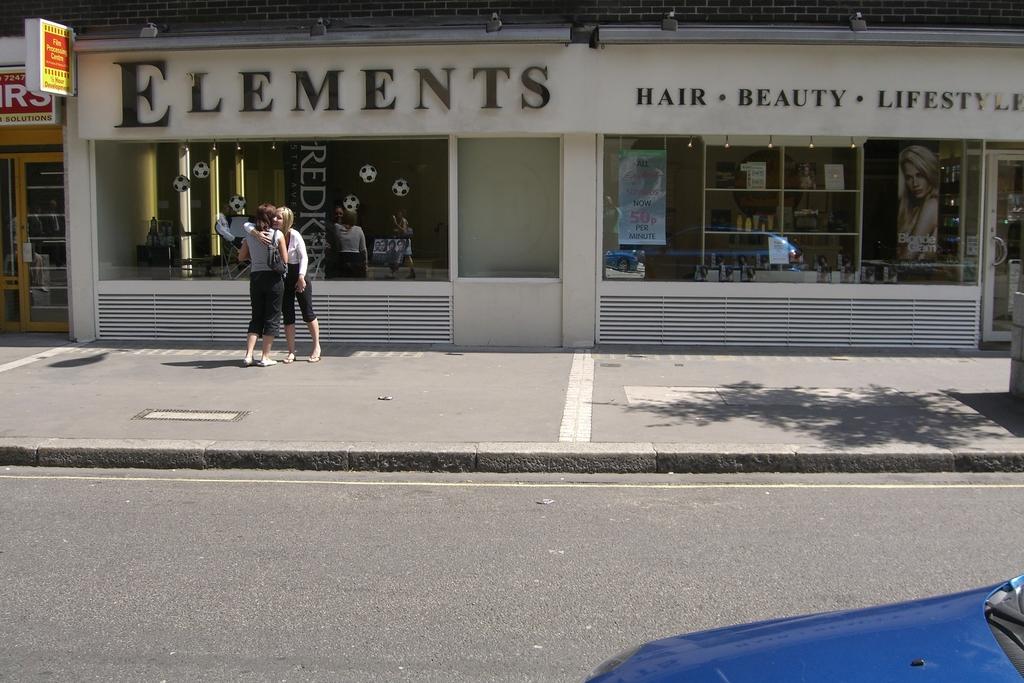What does elements specialize in?
Provide a succinct answer. Hair, beauty, lifestyle. What is the name of this store?
Your answer should be very brief. Elements. 